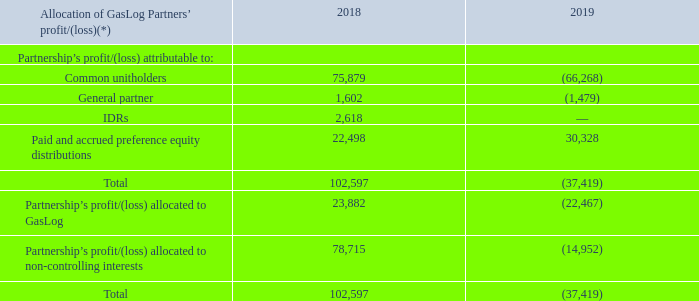GasLog Ltd. and its Subsidiaries Notes to the consolidated financial statements (Continued) For the years ended December 31, 2017, 2018 and 2019 (All amounts expressed in thousands of U.S. Dollars, except share and per share data)    4. Equity Transactions (Continued)
On February 26, 2019, the Partnership entered into a Third Amended and Restated Equity Distribution Agreement to further increase the size of the ATM Programme from $144,040 to $250,000. As of December 31, 2019, the unutilized portion of the ATM Programme is $126,556.
On April 1, 2019, GasLog Partners issued 49,850 common units in connection with the vesting of 24,925 RCUs and 24,925 PCUs under the GasLog Partners’ Plan at a price of $22.99 per unit.
On June 24, 2019, the Partnership Agreement was amended, effective June 30, 2019, to eliminate the IDRs in exchange for the issuance by the Partnership to GasLog of 2,532,911 common units and 2,490,000 Class B units (of which 415,000 are Class B-1 units, 415,000 are Class B-2 units, 415,000 are Class B-3 units, 415,000 are Class B-4 units, 415,000 are Class B-5 units and 415,000 are Class B-6 units), issued on June 30, 2019. The Class B units have all of the rights and obligations attached to the common units, except for voting rights and participation in distributions until such time as GasLog exercises its right to convert the Class B units to common units. The Class B units will become eligible for conversion on a one-for-one basis into common units at GasLog’s option on July 1, 2020, July 1, 2021, July 1, 2022, July 1, 2023, July 1, 2024 and July 1, 2025 for the Class B-1 units, Class B-2 units, Class B-3 units, Class B-4 units, Class B-5 units and the Class B-6 units, respectively. Following the IDR elimination, the allocation of GasLog Partners’ profit to the non-controlling interests is based on the revised distribution policy for available cash stated in the Partnership Agreement as amended, effective June 30, 2019, and under which 98% of the available cash is distributed to the common unitholders and 2% is distributed to the general partner. The updated earnings allocation applies to the total GasLog Partners’ profit for the three months ended June 30, 2019 and onwards.
* Excludes profits of GAS-fourteen Ltd., GAS-twenty seven Ltd. and GAS-twelve Ltd. for the period prior to their transfers to the Partnership on April 26, 2018, November 14, 2018 and April 1, 2019, respectively.
Dividends declared attributable to non-controlling interests included in the consolidated statement of changes in equity represent cash distributions to holders of common and preference units.
In the year ended December 31, 2019, the board of directors of the Partnership approved and declared cash distributions of $73,090 and of $31,036 for the common units and preference units, respectively, held by non-controlling interests.
What was the amount of cash distributions in 2019 for common units?
Answer scale should be: thousand. $73,090. How much of the ATM Programme is unutilized in 2019?
Answer scale should be: thousand. $126,556. What are the components of Class B units? Class b-1 units, class b-2 units, class b-3 units, class b-4 units, class b-5 units, class b-6 units. In which year was the paid and accrued preference equity distributions higher? 30,328 > 22,498
Answer: 2019. What was the change in size of the ATM Programme? $250,000 - $144,040 
Answer: 105960. What was the percentage change in Partnership’s profit/(loss) allocated to GasLog from 2018 to 2019?
Answer scale should be: percent. (-22,467  - 23,882)/23,882 
Answer: -194.08. 